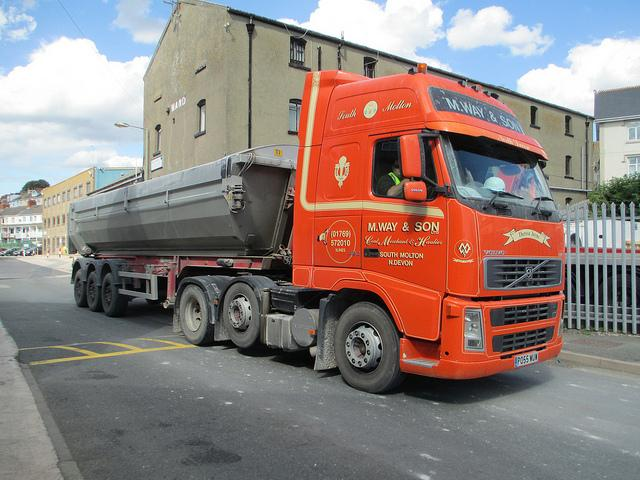What business park does this company operate out of? Please explain your reasoning. pathfields. The display of the bus shows the park but it does. 